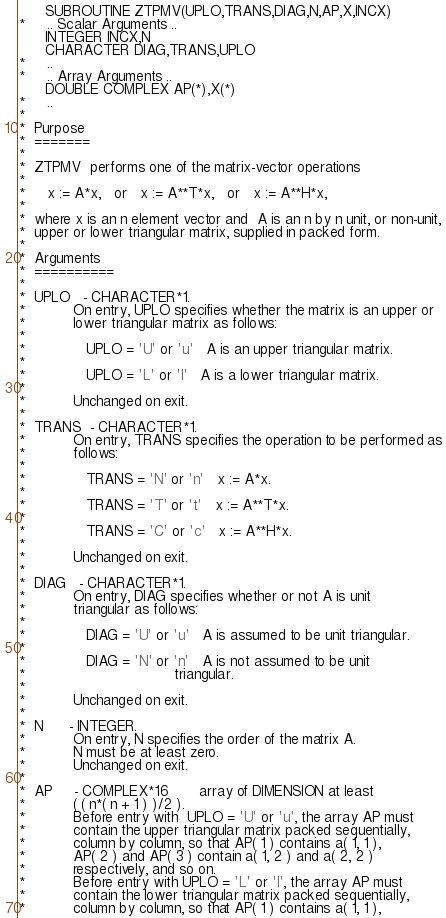<code> <loc_0><loc_0><loc_500><loc_500><_FORTRAN_>      SUBROUTINE ZTPMV(UPLO,TRANS,DIAG,N,AP,X,INCX)
*     .. Scalar Arguments ..
      INTEGER INCX,N
      CHARACTER DIAG,TRANS,UPLO
*     ..
*     .. Array Arguments ..
      DOUBLE COMPLEX AP(*),X(*)
*     ..
*
*  Purpose
*  =======
*
*  ZTPMV  performs one of the matrix-vector operations
*
*     x := A*x,   or   x := A**T*x,   or   x := A**H*x,
*
*  where x is an n element vector and  A is an n by n unit, or non-unit,
*  upper or lower triangular matrix, supplied in packed form.
*
*  Arguments
*  ==========
*
*  UPLO   - CHARACTER*1.
*           On entry, UPLO specifies whether the matrix is an upper or
*           lower triangular matrix as follows:
*
*              UPLO = 'U' or 'u'   A is an upper triangular matrix.
*
*              UPLO = 'L' or 'l'   A is a lower triangular matrix.
*
*           Unchanged on exit.
*
*  TRANS  - CHARACTER*1.
*           On entry, TRANS specifies the operation to be performed as
*           follows:
*
*              TRANS = 'N' or 'n'   x := A*x.
*
*              TRANS = 'T' or 't'   x := A**T*x.
*
*              TRANS = 'C' or 'c'   x := A**H*x.
*
*           Unchanged on exit.
*
*  DIAG   - CHARACTER*1.
*           On entry, DIAG specifies whether or not A is unit
*           triangular as follows:
*
*              DIAG = 'U' or 'u'   A is assumed to be unit triangular.
*
*              DIAG = 'N' or 'n'   A is not assumed to be unit
*                                  triangular.
*
*           Unchanged on exit.
*
*  N      - INTEGER.
*           On entry, N specifies the order of the matrix A.
*           N must be at least zero.
*           Unchanged on exit.
*
*  AP     - COMPLEX*16       array of DIMENSION at least
*           ( ( n*( n + 1 ) )/2 ).
*           Before entry with  UPLO = 'U' or 'u', the array AP must
*           contain the upper triangular matrix packed sequentially,
*           column by column, so that AP( 1 ) contains a( 1, 1 ),
*           AP( 2 ) and AP( 3 ) contain a( 1, 2 ) and a( 2, 2 )
*           respectively, and so on.
*           Before entry with UPLO = 'L' or 'l', the array AP must
*           contain the lower triangular matrix packed sequentially,
*           column by column, so that AP( 1 ) contains a( 1, 1 ),</code> 